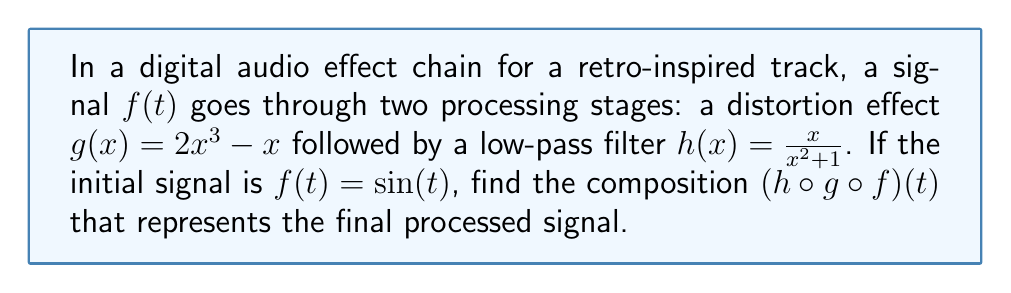Help me with this question. Let's approach this step-by-step:

1) We start with the initial signal $f(t) = \sin(t)$

2) The first effect applied is the distortion $g(x) = 2x^3 - x$
   Let's apply this to $f(t)$:
   $g(f(t)) = g(\sin(t)) = 2\sin^3(t) - \sin(t)$

3) Now we apply the low-pass filter $h(x) = \frac{x}{x^2 + 1}$ to the result of step 2:
   $h(g(f(t))) = h(2\sin^3(t) - \sin(t))$
   
   $= \frac{2\sin^3(t) - \sin(t)}{(2\sin^3(t) - \sin(t))^2 + 1}$

4) This can be simplified:
   $= \frac{2\sin^3(t) - \sin(t)}{4\sin^6(t) - 4\sin^4(t) + \sin^2(t) + 1}$

5) The final composition $(h \circ g \circ f)(t)$ is therefore:
   $$(h \circ g \circ f)(t) = \frac{2\sin^3(t) - \sin(t)}{4\sin^6(t) - 4\sin^4(t) + \sin^2(t) + 1}$$

This function represents the signal after it has passed through both the distortion and low-pass filter effects.
Answer: $$\frac{2\sin^3(t) - \sin(t)}{4\sin^6(t) - 4\sin^4(t) + \sin^2(t) + 1}$$ 